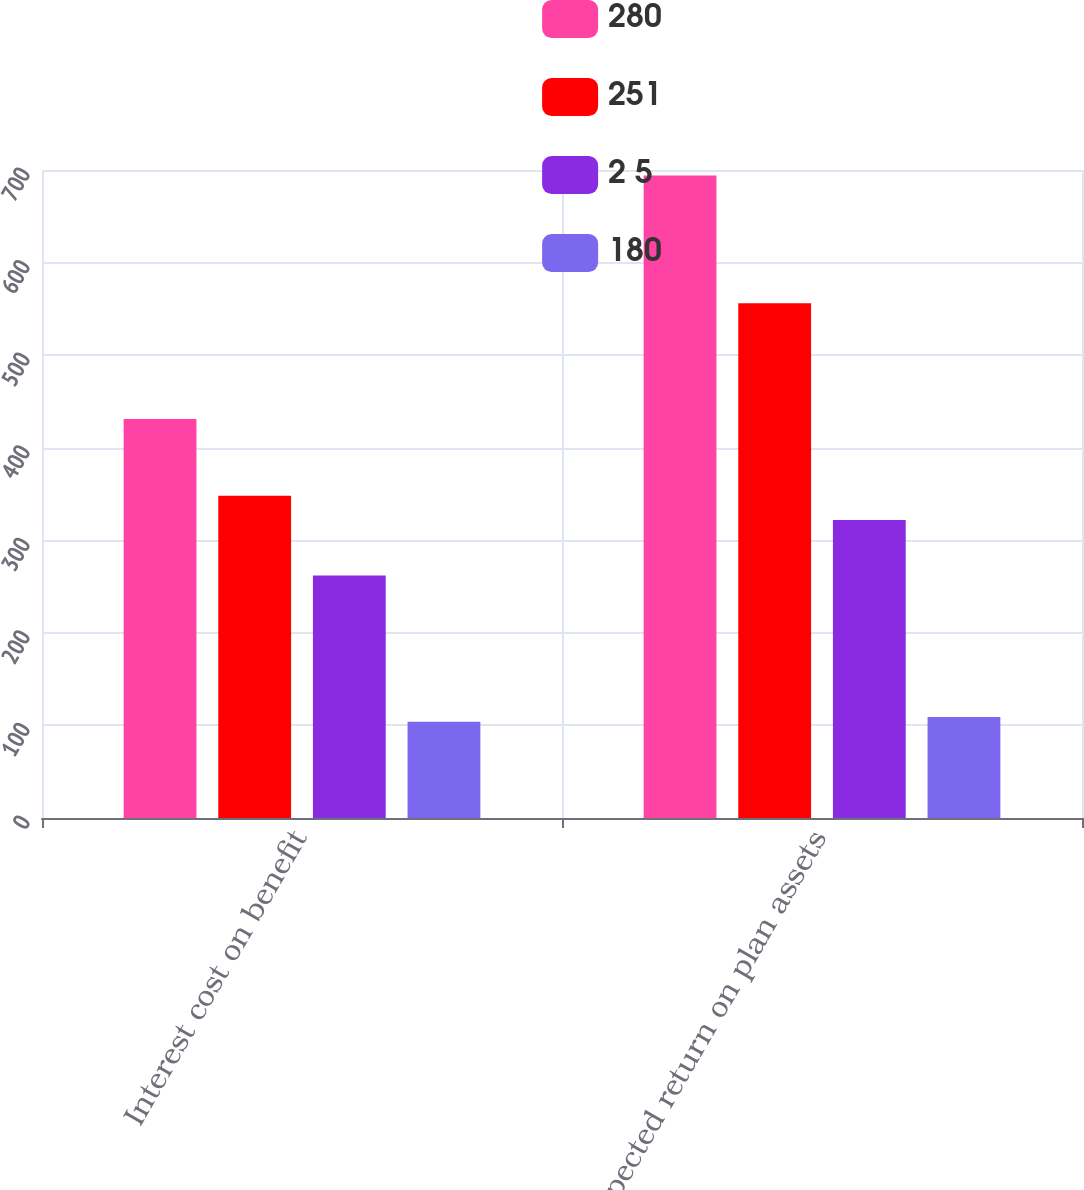Convert chart. <chart><loc_0><loc_0><loc_500><loc_500><stacked_bar_chart><ecel><fcel>Interest cost on benefit<fcel>Expected return on plan assets<nl><fcel>280<fcel>431<fcel>694<nl><fcel>251<fcel>348<fcel>556<nl><fcel>2 5<fcel>262<fcel>322<nl><fcel>180<fcel>104<fcel>109<nl></chart> 